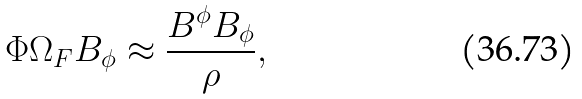Convert formula to latex. <formula><loc_0><loc_0><loc_500><loc_500>\Phi \Omega _ { F } B _ { \phi } \approx \frac { B ^ { \phi } B _ { \phi } } { \rho } ,</formula> 